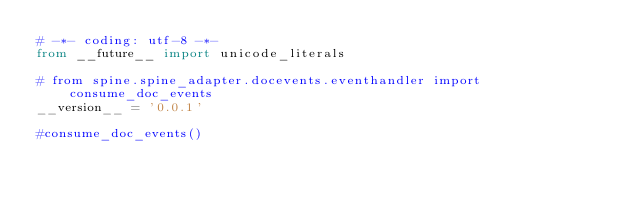Convert code to text. <code><loc_0><loc_0><loc_500><loc_500><_Python_># -*- coding: utf-8 -*-
from __future__ import unicode_literals

# from spine.spine_adapter.docevents.eventhandler import consume_doc_events
__version__ = '0.0.1'

#consume_doc_events()
</code> 